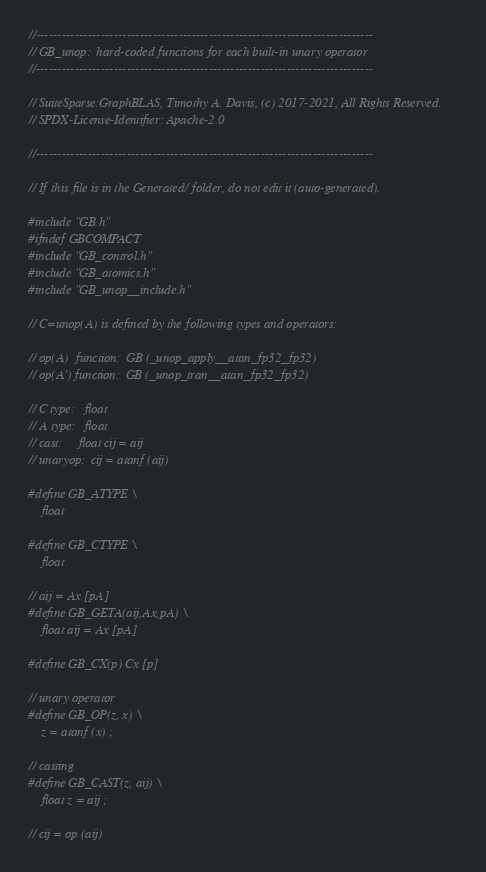<code> <loc_0><loc_0><loc_500><loc_500><_C_>//------------------------------------------------------------------------------
// GB_unop:  hard-coded functions for each built-in unary operator
//------------------------------------------------------------------------------

// SuiteSparse:GraphBLAS, Timothy A. Davis, (c) 2017-2021, All Rights Reserved.
// SPDX-License-Identifier: Apache-2.0

//------------------------------------------------------------------------------

// If this file is in the Generated/ folder, do not edit it (auto-generated).

#include "GB.h"
#ifndef GBCOMPACT
#include "GB_control.h"
#include "GB_atomics.h"
#include "GB_unop__include.h"

// C=unop(A) is defined by the following types and operators:

// op(A)  function:  GB (_unop_apply__atan_fp32_fp32)
// op(A') function:  GB (_unop_tran__atan_fp32_fp32)

// C type:   float
// A type:   float
// cast:     float cij = aij
// unaryop:  cij = atanf (aij)

#define GB_ATYPE \
    float

#define GB_CTYPE \
    float

// aij = Ax [pA]
#define GB_GETA(aij,Ax,pA) \
    float aij = Ax [pA]

#define GB_CX(p) Cx [p]

// unary operator
#define GB_OP(z, x) \
    z = atanf (x) ;

// casting
#define GB_CAST(z, aij) \
    float z = aij ;

// cij = op (aij)</code> 